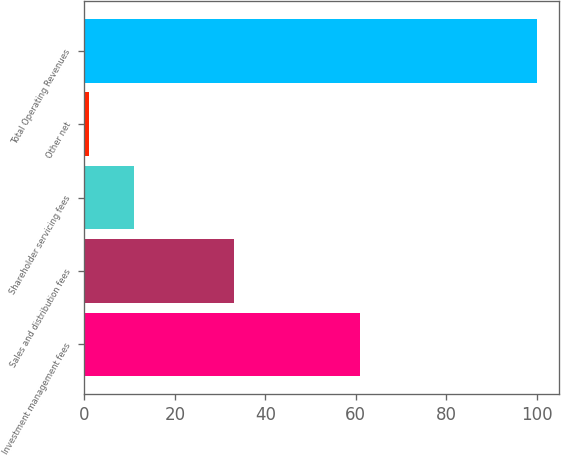Convert chart. <chart><loc_0><loc_0><loc_500><loc_500><bar_chart><fcel>Investment management fees<fcel>Sales and distribution fees<fcel>Shareholder servicing fees<fcel>Other net<fcel>Total Operating Revenues<nl><fcel>61<fcel>33<fcel>10.9<fcel>1<fcel>100<nl></chart> 